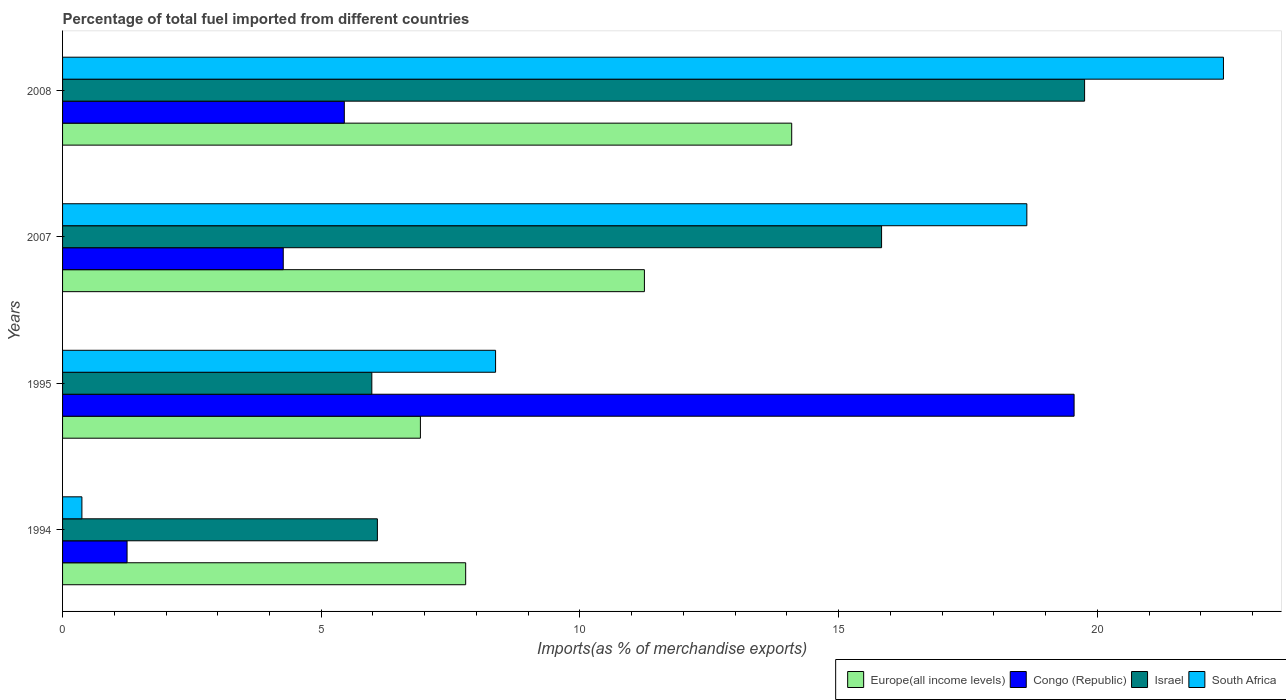How many different coloured bars are there?
Give a very brief answer. 4. How many groups of bars are there?
Keep it short and to the point. 4. Are the number of bars per tick equal to the number of legend labels?
Offer a very short reply. Yes. Are the number of bars on each tick of the Y-axis equal?
Your answer should be compact. Yes. How many bars are there on the 1st tick from the bottom?
Give a very brief answer. 4. What is the percentage of imports to different countries in South Africa in 2007?
Make the answer very short. 18.64. Across all years, what is the maximum percentage of imports to different countries in Congo (Republic)?
Keep it short and to the point. 19.55. Across all years, what is the minimum percentage of imports to different countries in Israel?
Give a very brief answer. 5.98. In which year was the percentage of imports to different countries in Europe(all income levels) minimum?
Your answer should be very brief. 1995. What is the total percentage of imports to different countries in Congo (Republic) in the graph?
Offer a very short reply. 30.51. What is the difference between the percentage of imports to different countries in Congo (Republic) in 1995 and that in 2007?
Keep it short and to the point. 15.29. What is the difference between the percentage of imports to different countries in Congo (Republic) in 1994 and the percentage of imports to different countries in Europe(all income levels) in 1995?
Your answer should be very brief. -5.67. What is the average percentage of imports to different countries in Europe(all income levels) per year?
Your answer should be compact. 10.01. In the year 2008, what is the difference between the percentage of imports to different countries in Europe(all income levels) and percentage of imports to different countries in Israel?
Offer a terse response. -5.66. In how many years, is the percentage of imports to different countries in South Africa greater than 14 %?
Your answer should be compact. 2. What is the ratio of the percentage of imports to different countries in Israel in 2007 to that in 2008?
Your answer should be very brief. 0.8. Is the difference between the percentage of imports to different countries in Europe(all income levels) in 2007 and 2008 greater than the difference between the percentage of imports to different countries in Israel in 2007 and 2008?
Offer a very short reply. Yes. What is the difference between the highest and the second highest percentage of imports to different countries in Congo (Republic)?
Your response must be concise. 14.11. What is the difference between the highest and the lowest percentage of imports to different countries in Israel?
Keep it short and to the point. 13.78. Is the sum of the percentage of imports to different countries in South Africa in 1994 and 2008 greater than the maximum percentage of imports to different countries in Congo (Republic) across all years?
Offer a terse response. Yes. Is it the case that in every year, the sum of the percentage of imports to different countries in South Africa and percentage of imports to different countries in Europe(all income levels) is greater than the sum of percentage of imports to different countries in Israel and percentage of imports to different countries in Congo (Republic)?
Ensure brevity in your answer.  No. What does the 1st bar from the top in 2007 represents?
Keep it short and to the point. South Africa. Is it the case that in every year, the sum of the percentage of imports to different countries in Israel and percentage of imports to different countries in Europe(all income levels) is greater than the percentage of imports to different countries in South Africa?
Provide a short and direct response. Yes. How many bars are there?
Ensure brevity in your answer.  16. What is the difference between two consecutive major ticks on the X-axis?
Your answer should be compact. 5. Are the values on the major ticks of X-axis written in scientific E-notation?
Ensure brevity in your answer.  No. How many legend labels are there?
Give a very brief answer. 4. What is the title of the graph?
Provide a short and direct response. Percentage of total fuel imported from different countries. What is the label or title of the X-axis?
Your answer should be compact. Imports(as % of merchandise exports). What is the label or title of the Y-axis?
Offer a terse response. Years. What is the Imports(as % of merchandise exports) in Europe(all income levels) in 1994?
Give a very brief answer. 7.79. What is the Imports(as % of merchandise exports) in Congo (Republic) in 1994?
Offer a terse response. 1.25. What is the Imports(as % of merchandise exports) of Israel in 1994?
Your response must be concise. 6.09. What is the Imports(as % of merchandise exports) of South Africa in 1994?
Keep it short and to the point. 0.37. What is the Imports(as % of merchandise exports) of Europe(all income levels) in 1995?
Your answer should be compact. 6.92. What is the Imports(as % of merchandise exports) of Congo (Republic) in 1995?
Offer a very short reply. 19.55. What is the Imports(as % of merchandise exports) of Israel in 1995?
Offer a terse response. 5.98. What is the Imports(as % of merchandise exports) in South Africa in 1995?
Offer a very short reply. 8.37. What is the Imports(as % of merchandise exports) in Europe(all income levels) in 2007?
Your answer should be compact. 11.25. What is the Imports(as % of merchandise exports) in Congo (Republic) in 2007?
Your response must be concise. 4.27. What is the Imports(as % of merchandise exports) in Israel in 2007?
Give a very brief answer. 15.83. What is the Imports(as % of merchandise exports) of South Africa in 2007?
Your answer should be compact. 18.64. What is the Imports(as % of merchandise exports) of Europe(all income levels) in 2008?
Keep it short and to the point. 14.09. What is the Imports(as % of merchandise exports) in Congo (Republic) in 2008?
Offer a terse response. 5.45. What is the Imports(as % of merchandise exports) in Israel in 2008?
Your response must be concise. 19.76. What is the Imports(as % of merchandise exports) of South Africa in 2008?
Offer a terse response. 22.44. Across all years, what is the maximum Imports(as % of merchandise exports) of Europe(all income levels)?
Give a very brief answer. 14.09. Across all years, what is the maximum Imports(as % of merchandise exports) of Congo (Republic)?
Your response must be concise. 19.55. Across all years, what is the maximum Imports(as % of merchandise exports) of Israel?
Your answer should be compact. 19.76. Across all years, what is the maximum Imports(as % of merchandise exports) of South Africa?
Make the answer very short. 22.44. Across all years, what is the minimum Imports(as % of merchandise exports) in Europe(all income levels)?
Your answer should be very brief. 6.92. Across all years, what is the minimum Imports(as % of merchandise exports) of Congo (Republic)?
Offer a very short reply. 1.25. Across all years, what is the minimum Imports(as % of merchandise exports) in Israel?
Offer a terse response. 5.98. Across all years, what is the minimum Imports(as % of merchandise exports) in South Africa?
Your response must be concise. 0.37. What is the total Imports(as % of merchandise exports) in Europe(all income levels) in the graph?
Make the answer very short. 40.05. What is the total Imports(as % of merchandise exports) in Congo (Republic) in the graph?
Offer a terse response. 30.51. What is the total Imports(as % of merchandise exports) in Israel in the graph?
Ensure brevity in your answer.  47.65. What is the total Imports(as % of merchandise exports) of South Africa in the graph?
Ensure brevity in your answer.  49.82. What is the difference between the Imports(as % of merchandise exports) of Europe(all income levels) in 1994 and that in 1995?
Your answer should be compact. 0.88. What is the difference between the Imports(as % of merchandise exports) in Congo (Republic) in 1994 and that in 1995?
Your response must be concise. -18.31. What is the difference between the Imports(as % of merchandise exports) of Israel in 1994 and that in 1995?
Your answer should be very brief. 0.11. What is the difference between the Imports(as % of merchandise exports) in South Africa in 1994 and that in 1995?
Your answer should be compact. -8. What is the difference between the Imports(as % of merchandise exports) in Europe(all income levels) in 1994 and that in 2007?
Your response must be concise. -3.45. What is the difference between the Imports(as % of merchandise exports) of Congo (Republic) in 1994 and that in 2007?
Your answer should be very brief. -3.02. What is the difference between the Imports(as % of merchandise exports) in Israel in 1994 and that in 2007?
Provide a short and direct response. -9.75. What is the difference between the Imports(as % of merchandise exports) of South Africa in 1994 and that in 2007?
Offer a terse response. -18.26. What is the difference between the Imports(as % of merchandise exports) of Europe(all income levels) in 1994 and that in 2008?
Your answer should be compact. -6.3. What is the difference between the Imports(as % of merchandise exports) of Congo (Republic) in 1994 and that in 2008?
Provide a succinct answer. -4.2. What is the difference between the Imports(as % of merchandise exports) of Israel in 1994 and that in 2008?
Give a very brief answer. -13.67. What is the difference between the Imports(as % of merchandise exports) in South Africa in 1994 and that in 2008?
Your response must be concise. -22.07. What is the difference between the Imports(as % of merchandise exports) of Europe(all income levels) in 1995 and that in 2007?
Your answer should be very brief. -4.33. What is the difference between the Imports(as % of merchandise exports) of Congo (Republic) in 1995 and that in 2007?
Your response must be concise. 15.29. What is the difference between the Imports(as % of merchandise exports) in Israel in 1995 and that in 2007?
Offer a very short reply. -9.85. What is the difference between the Imports(as % of merchandise exports) in South Africa in 1995 and that in 2007?
Ensure brevity in your answer.  -10.27. What is the difference between the Imports(as % of merchandise exports) in Europe(all income levels) in 1995 and that in 2008?
Provide a short and direct response. -7.18. What is the difference between the Imports(as % of merchandise exports) of Congo (Republic) in 1995 and that in 2008?
Ensure brevity in your answer.  14.11. What is the difference between the Imports(as % of merchandise exports) in Israel in 1995 and that in 2008?
Your answer should be compact. -13.78. What is the difference between the Imports(as % of merchandise exports) in South Africa in 1995 and that in 2008?
Your answer should be compact. -14.07. What is the difference between the Imports(as % of merchandise exports) in Europe(all income levels) in 2007 and that in 2008?
Your response must be concise. -2.85. What is the difference between the Imports(as % of merchandise exports) of Congo (Republic) in 2007 and that in 2008?
Offer a terse response. -1.18. What is the difference between the Imports(as % of merchandise exports) in Israel in 2007 and that in 2008?
Provide a succinct answer. -3.92. What is the difference between the Imports(as % of merchandise exports) in South Africa in 2007 and that in 2008?
Ensure brevity in your answer.  -3.8. What is the difference between the Imports(as % of merchandise exports) of Europe(all income levels) in 1994 and the Imports(as % of merchandise exports) of Congo (Republic) in 1995?
Keep it short and to the point. -11.76. What is the difference between the Imports(as % of merchandise exports) of Europe(all income levels) in 1994 and the Imports(as % of merchandise exports) of Israel in 1995?
Your answer should be very brief. 1.81. What is the difference between the Imports(as % of merchandise exports) of Europe(all income levels) in 1994 and the Imports(as % of merchandise exports) of South Africa in 1995?
Offer a very short reply. -0.58. What is the difference between the Imports(as % of merchandise exports) in Congo (Republic) in 1994 and the Imports(as % of merchandise exports) in Israel in 1995?
Offer a terse response. -4.73. What is the difference between the Imports(as % of merchandise exports) in Congo (Republic) in 1994 and the Imports(as % of merchandise exports) in South Africa in 1995?
Make the answer very short. -7.12. What is the difference between the Imports(as % of merchandise exports) of Israel in 1994 and the Imports(as % of merchandise exports) of South Africa in 1995?
Provide a short and direct response. -2.28. What is the difference between the Imports(as % of merchandise exports) of Europe(all income levels) in 1994 and the Imports(as % of merchandise exports) of Congo (Republic) in 2007?
Your answer should be compact. 3.53. What is the difference between the Imports(as % of merchandise exports) in Europe(all income levels) in 1994 and the Imports(as % of merchandise exports) in Israel in 2007?
Your answer should be compact. -8.04. What is the difference between the Imports(as % of merchandise exports) of Europe(all income levels) in 1994 and the Imports(as % of merchandise exports) of South Africa in 2007?
Give a very brief answer. -10.85. What is the difference between the Imports(as % of merchandise exports) in Congo (Republic) in 1994 and the Imports(as % of merchandise exports) in Israel in 2007?
Your response must be concise. -14.58. What is the difference between the Imports(as % of merchandise exports) in Congo (Republic) in 1994 and the Imports(as % of merchandise exports) in South Africa in 2007?
Make the answer very short. -17.39. What is the difference between the Imports(as % of merchandise exports) of Israel in 1994 and the Imports(as % of merchandise exports) of South Africa in 2007?
Provide a succinct answer. -12.55. What is the difference between the Imports(as % of merchandise exports) in Europe(all income levels) in 1994 and the Imports(as % of merchandise exports) in Congo (Republic) in 2008?
Ensure brevity in your answer.  2.35. What is the difference between the Imports(as % of merchandise exports) of Europe(all income levels) in 1994 and the Imports(as % of merchandise exports) of Israel in 2008?
Make the answer very short. -11.96. What is the difference between the Imports(as % of merchandise exports) of Europe(all income levels) in 1994 and the Imports(as % of merchandise exports) of South Africa in 2008?
Your response must be concise. -14.65. What is the difference between the Imports(as % of merchandise exports) in Congo (Republic) in 1994 and the Imports(as % of merchandise exports) in Israel in 2008?
Your answer should be compact. -18.51. What is the difference between the Imports(as % of merchandise exports) of Congo (Republic) in 1994 and the Imports(as % of merchandise exports) of South Africa in 2008?
Make the answer very short. -21.19. What is the difference between the Imports(as % of merchandise exports) of Israel in 1994 and the Imports(as % of merchandise exports) of South Africa in 2008?
Provide a short and direct response. -16.35. What is the difference between the Imports(as % of merchandise exports) of Europe(all income levels) in 1995 and the Imports(as % of merchandise exports) of Congo (Republic) in 2007?
Offer a very short reply. 2.65. What is the difference between the Imports(as % of merchandise exports) in Europe(all income levels) in 1995 and the Imports(as % of merchandise exports) in Israel in 2007?
Ensure brevity in your answer.  -8.91. What is the difference between the Imports(as % of merchandise exports) in Europe(all income levels) in 1995 and the Imports(as % of merchandise exports) in South Africa in 2007?
Offer a terse response. -11.72. What is the difference between the Imports(as % of merchandise exports) of Congo (Republic) in 1995 and the Imports(as % of merchandise exports) of Israel in 2007?
Keep it short and to the point. 3.72. What is the difference between the Imports(as % of merchandise exports) of Congo (Republic) in 1995 and the Imports(as % of merchandise exports) of South Africa in 2007?
Give a very brief answer. 0.91. What is the difference between the Imports(as % of merchandise exports) in Israel in 1995 and the Imports(as % of merchandise exports) in South Africa in 2007?
Offer a very short reply. -12.66. What is the difference between the Imports(as % of merchandise exports) in Europe(all income levels) in 1995 and the Imports(as % of merchandise exports) in Congo (Republic) in 2008?
Keep it short and to the point. 1.47. What is the difference between the Imports(as % of merchandise exports) of Europe(all income levels) in 1995 and the Imports(as % of merchandise exports) of Israel in 2008?
Ensure brevity in your answer.  -12.84. What is the difference between the Imports(as % of merchandise exports) of Europe(all income levels) in 1995 and the Imports(as % of merchandise exports) of South Africa in 2008?
Give a very brief answer. -15.52. What is the difference between the Imports(as % of merchandise exports) of Congo (Republic) in 1995 and the Imports(as % of merchandise exports) of Israel in 2008?
Offer a terse response. -0.2. What is the difference between the Imports(as % of merchandise exports) in Congo (Republic) in 1995 and the Imports(as % of merchandise exports) in South Africa in 2008?
Keep it short and to the point. -2.89. What is the difference between the Imports(as % of merchandise exports) of Israel in 1995 and the Imports(as % of merchandise exports) of South Africa in 2008?
Make the answer very short. -16.46. What is the difference between the Imports(as % of merchandise exports) in Europe(all income levels) in 2007 and the Imports(as % of merchandise exports) in Congo (Republic) in 2008?
Offer a terse response. 5.8. What is the difference between the Imports(as % of merchandise exports) of Europe(all income levels) in 2007 and the Imports(as % of merchandise exports) of Israel in 2008?
Your response must be concise. -8.51. What is the difference between the Imports(as % of merchandise exports) of Europe(all income levels) in 2007 and the Imports(as % of merchandise exports) of South Africa in 2008?
Offer a very short reply. -11.19. What is the difference between the Imports(as % of merchandise exports) in Congo (Republic) in 2007 and the Imports(as % of merchandise exports) in Israel in 2008?
Provide a succinct answer. -15.49. What is the difference between the Imports(as % of merchandise exports) in Congo (Republic) in 2007 and the Imports(as % of merchandise exports) in South Africa in 2008?
Provide a succinct answer. -18.17. What is the difference between the Imports(as % of merchandise exports) of Israel in 2007 and the Imports(as % of merchandise exports) of South Africa in 2008?
Offer a terse response. -6.61. What is the average Imports(as % of merchandise exports) in Europe(all income levels) per year?
Make the answer very short. 10.01. What is the average Imports(as % of merchandise exports) in Congo (Republic) per year?
Your answer should be compact. 7.63. What is the average Imports(as % of merchandise exports) in Israel per year?
Keep it short and to the point. 11.91. What is the average Imports(as % of merchandise exports) of South Africa per year?
Make the answer very short. 12.46. In the year 1994, what is the difference between the Imports(as % of merchandise exports) in Europe(all income levels) and Imports(as % of merchandise exports) in Congo (Republic)?
Give a very brief answer. 6.55. In the year 1994, what is the difference between the Imports(as % of merchandise exports) in Europe(all income levels) and Imports(as % of merchandise exports) in Israel?
Your answer should be compact. 1.71. In the year 1994, what is the difference between the Imports(as % of merchandise exports) of Europe(all income levels) and Imports(as % of merchandise exports) of South Africa?
Offer a terse response. 7.42. In the year 1994, what is the difference between the Imports(as % of merchandise exports) of Congo (Republic) and Imports(as % of merchandise exports) of Israel?
Offer a terse response. -4.84. In the year 1994, what is the difference between the Imports(as % of merchandise exports) in Congo (Republic) and Imports(as % of merchandise exports) in South Africa?
Provide a succinct answer. 0.87. In the year 1994, what is the difference between the Imports(as % of merchandise exports) in Israel and Imports(as % of merchandise exports) in South Africa?
Keep it short and to the point. 5.71. In the year 1995, what is the difference between the Imports(as % of merchandise exports) of Europe(all income levels) and Imports(as % of merchandise exports) of Congo (Republic)?
Provide a succinct answer. -12.64. In the year 1995, what is the difference between the Imports(as % of merchandise exports) of Europe(all income levels) and Imports(as % of merchandise exports) of Israel?
Provide a succinct answer. 0.94. In the year 1995, what is the difference between the Imports(as % of merchandise exports) in Europe(all income levels) and Imports(as % of merchandise exports) in South Africa?
Make the answer very short. -1.45. In the year 1995, what is the difference between the Imports(as % of merchandise exports) of Congo (Republic) and Imports(as % of merchandise exports) of Israel?
Offer a very short reply. 13.57. In the year 1995, what is the difference between the Imports(as % of merchandise exports) of Congo (Republic) and Imports(as % of merchandise exports) of South Africa?
Offer a terse response. 11.18. In the year 1995, what is the difference between the Imports(as % of merchandise exports) of Israel and Imports(as % of merchandise exports) of South Africa?
Offer a very short reply. -2.39. In the year 2007, what is the difference between the Imports(as % of merchandise exports) in Europe(all income levels) and Imports(as % of merchandise exports) in Congo (Republic)?
Make the answer very short. 6.98. In the year 2007, what is the difference between the Imports(as % of merchandise exports) of Europe(all income levels) and Imports(as % of merchandise exports) of Israel?
Your answer should be compact. -4.58. In the year 2007, what is the difference between the Imports(as % of merchandise exports) in Europe(all income levels) and Imports(as % of merchandise exports) in South Africa?
Your answer should be very brief. -7.39. In the year 2007, what is the difference between the Imports(as % of merchandise exports) of Congo (Republic) and Imports(as % of merchandise exports) of Israel?
Provide a short and direct response. -11.57. In the year 2007, what is the difference between the Imports(as % of merchandise exports) of Congo (Republic) and Imports(as % of merchandise exports) of South Africa?
Keep it short and to the point. -14.37. In the year 2007, what is the difference between the Imports(as % of merchandise exports) in Israel and Imports(as % of merchandise exports) in South Africa?
Offer a very short reply. -2.81. In the year 2008, what is the difference between the Imports(as % of merchandise exports) of Europe(all income levels) and Imports(as % of merchandise exports) of Congo (Republic)?
Provide a succinct answer. 8.65. In the year 2008, what is the difference between the Imports(as % of merchandise exports) of Europe(all income levels) and Imports(as % of merchandise exports) of Israel?
Provide a short and direct response. -5.66. In the year 2008, what is the difference between the Imports(as % of merchandise exports) of Europe(all income levels) and Imports(as % of merchandise exports) of South Africa?
Provide a succinct answer. -8.35. In the year 2008, what is the difference between the Imports(as % of merchandise exports) in Congo (Republic) and Imports(as % of merchandise exports) in Israel?
Your answer should be compact. -14.31. In the year 2008, what is the difference between the Imports(as % of merchandise exports) of Congo (Republic) and Imports(as % of merchandise exports) of South Africa?
Provide a short and direct response. -16.99. In the year 2008, what is the difference between the Imports(as % of merchandise exports) of Israel and Imports(as % of merchandise exports) of South Africa?
Provide a short and direct response. -2.68. What is the ratio of the Imports(as % of merchandise exports) of Europe(all income levels) in 1994 to that in 1995?
Ensure brevity in your answer.  1.13. What is the ratio of the Imports(as % of merchandise exports) in Congo (Republic) in 1994 to that in 1995?
Keep it short and to the point. 0.06. What is the ratio of the Imports(as % of merchandise exports) in South Africa in 1994 to that in 1995?
Ensure brevity in your answer.  0.04. What is the ratio of the Imports(as % of merchandise exports) of Europe(all income levels) in 1994 to that in 2007?
Offer a terse response. 0.69. What is the ratio of the Imports(as % of merchandise exports) in Congo (Republic) in 1994 to that in 2007?
Offer a very short reply. 0.29. What is the ratio of the Imports(as % of merchandise exports) of Israel in 1994 to that in 2007?
Offer a very short reply. 0.38. What is the ratio of the Imports(as % of merchandise exports) of South Africa in 1994 to that in 2007?
Keep it short and to the point. 0.02. What is the ratio of the Imports(as % of merchandise exports) in Europe(all income levels) in 1994 to that in 2008?
Your answer should be very brief. 0.55. What is the ratio of the Imports(as % of merchandise exports) in Congo (Republic) in 1994 to that in 2008?
Provide a short and direct response. 0.23. What is the ratio of the Imports(as % of merchandise exports) in Israel in 1994 to that in 2008?
Your answer should be very brief. 0.31. What is the ratio of the Imports(as % of merchandise exports) of South Africa in 1994 to that in 2008?
Offer a terse response. 0.02. What is the ratio of the Imports(as % of merchandise exports) of Europe(all income levels) in 1995 to that in 2007?
Offer a very short reply. 0.61. What is the ratio of the Imports(as % of merchandise exports) of Congo (Republic) in 1995 to that in 2007?
Provide a short and direct response. 4.58. What is the ratio of the Imports(as % of merchandise exports) in Israel in 1995 to that in 2007?
Provide a short and direct response. 0.38. What is the ratio of the Imports(as % of merchandise exports) of South Africa in 1995 to that in 2007?
Your answer should be compact. 0.45. What is the ratio of the Imports(as % of merchandise exports) in Europe(all income levels) in 1995 to that in 2008?
Offer a very short reply. 0.49. What is the ratio of the Imports(as % of merchandise exports) of Congo (Republic) in 1995 to that in 2008?
Make the answer very short. 3.59. What is the ratio of the Imports(as % of merchandise exports) in Israel in 1995 to that in 2008?
Offer a very short reply. 0.3. What is the ratio of the Imports(as % of merchandise exports) in South Africa in 1995 to that in 2008?
Give a very brief answer. 0.37. What is the ratio of the Imports(as % of merchandise exports) in Europe(all income levels) in 2007 to that in 2008?
Offer a very short reply. 0.8. What is the ratio of the Imports(as % of merchandise exports) in Congo (Republic) in 2007 to that in 2008?
Your response must be concise. 0.78. What is the ratio of the Imports(as % of merchandise exports) in Israel in 2007 to that in 2008?
Ensure brevity in your answer.  0.8. What is the ratio of the Imports(as % of merchandise exports) of South Africa in 2007 to that in 2008?
Your response must be concise. 0.83. What is the difference between the highest and the second highest Imports(as % of merchandise exports) in Europe(all income levels)?
Your response must be concise. 2.85. What is the difference between the highest and the second highest Imports(as % of merchandise exports) in Congo (Republic)?
Your answer should be very brief. 14.11. What is the difference between the highest and the second highest Imports(as % of merchandise exports) of Israel?
Offer a very short reply. 3.92. What is the difference between the highest and the second highest Imports(as % of merchandise exports) in South Africa?
Give a very brief answer. 3.8. What is the difference between the highest and the lowest Imports(as % of merchandise exports) of Europe(all income levels)?
Provide a succinct answer. 7.18. What is the difference between the highest and the lowest Imports(as % of merchandise exports) of Congo (Republic)?
Make the answer very short. 18.31. What is the difference between the highest and the lowest Imports(as % of merchandise exports) in Israel?
Provide a succinct answer. 13.78. What is the difference between the highest and the lowest Imports(as % of merchandise exports) of South Africa?
Offer a terse response. 22.07. 